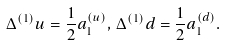<formula> <loc_0><loc_0><loc_500><loc_500>\Delta ^ { ( 1 ) } u = \frac { 1 } { 2 } a _ { 1 } ^ { ( u ) } , \, \Delta ^ { ( 1 ) } d = \frac { 1 } { 2 } a _ { 1 } ^ { ( d ) } .</formula> 